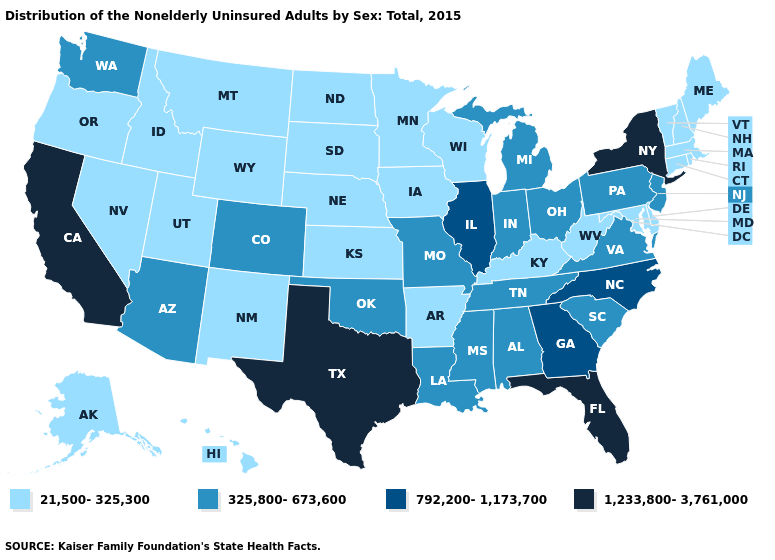How many symbols are there in the legend?
Give a very brief answer. 4. What is the lowest value in the Northeast?
Answer briefly. 21,500-325,300. What is the value of New Hampshire?
Give a very brief answer. 21,500-325,300. Among the states that border Illinois , does Missouri have the highest value?
Quick response, please. Yes. Name the states that have a value in the range 21,500-325,300?
Keep it brief. Alaska, Arkansas, Connecticut, Delaware, Hawaii, Idaho, Iowa, Kansas, Kentucky, Maine, Maryland, Massachusetts, Minnesota, Montana, Nebraska, Nevada, New Hampshire, New Mexico, North Dakota, Oregon, Rhode Island, South Dakota, Utah, Vermont, West Virginia, Wisconsin, Wyoming. Name the states that have a value in the range 792,200-1,173,700?
Write a very short answer. Georgia, Illinois, North Carolina. Name the states that have a value in the range 792,200-1,173,700?
Be succinct. Georgia, Illinois, North Carolina. Does the map have missing data?
Quick response, please. No. Does Massachusetts have the highest value in the Northeast?
Quick response, please. No. Name the states that have a value in the range 1,233,800-3,761,000?
Quick response, please. California, Florida, New York, Texas. What is the value of Ohio?
Be succinct. 325,800-673,600. Name the states that have a value in the range 325,800-673,600?
Write a very short answer. Alabama, Arizona, Colorado, Indiana, Louisiana, Michigan, Mississippi, Missouri, New Jersey, Ohio, Oklahoma, Pennsylvania, South Carolina, Tennessee, Virginia, Washington. What is the value of Wyoming?
Short answer required. 21,500-325,300. Name the states that have a value in the range 1,233,800-3,761,000?
Concise answer only. California, Florida, New York, Texas. 